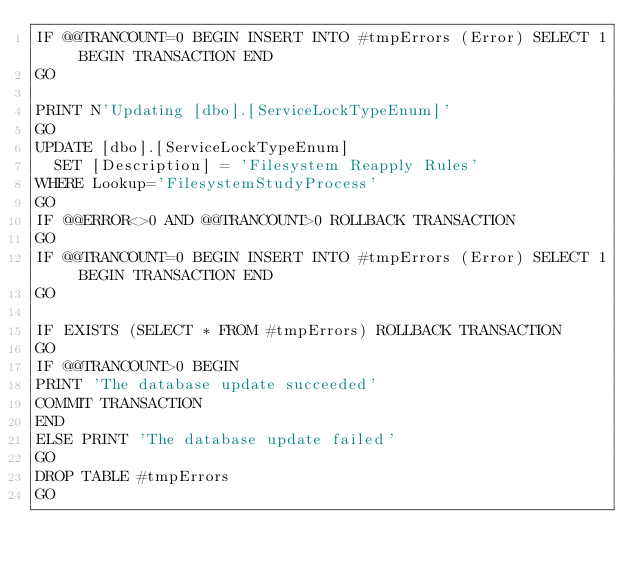<code> <loc_0><loc_0><loc_500><loc_500><_SQL_>IF @@TRANCOUNT=0 BEGIN INSERT INTO #tmpErrors (Error) SELECT 1 BEGIN TRANSACTION END
GO

PRINT N'Updating [dbo].[ServiceLockTypeEnum]'
GO
UPDATE [dbo].[ServiceLockTypeEnum]
  SET [Description] = 'Filesystem Reapply Rules'
WHERE Lookup='FilesystemStudyProcess'
GO
IF @@ERROR<>0 AND @@TRANCOUNT>0 ROLLBACK TRANSACTION
GO
IF @@TRANCOUNT=0 BEGIN INSERT INTO #tmpErrors (Error) SELECT 1 BEGIN TRANSACTION END
GO

IF EXISTS (SELECT * FROM #tmpErrors) ROLLBACK TRANSACTION
GO
IF @@TRANCOUNT>0 BEGIN
PRINT 'The database update succeeded'
COMMIT TRANSACTION
END
ELSE PRINT 'The database update failed'
GO
DROP TABLE #tmpErrors
GO
</code> 